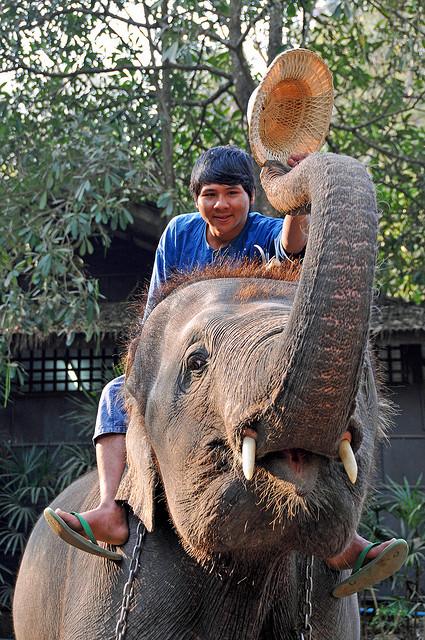Are the elephant's tusks long?
Write a very short answer. No. Is the boy wearing a hat?
Answer briefly. No. What is in the elephant's trunk?
Keep it brief. Hat. Is there someone on the elephant?
Quick response, please. Yes. 